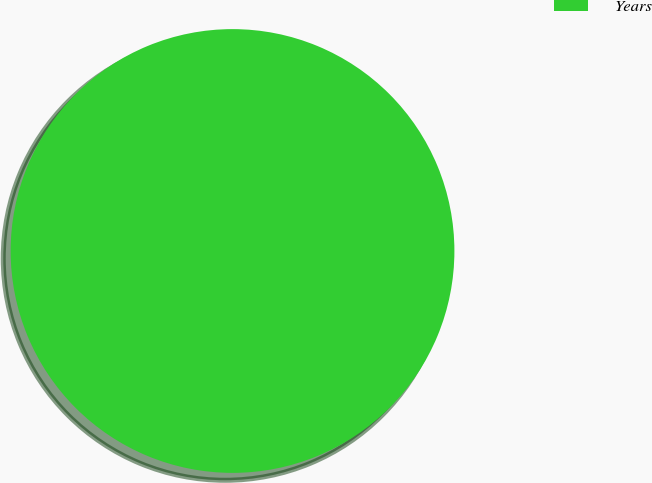Convert chart. <chart><loc_0><loc_0><loc_500><loc_500><pie_chart><fcel>Years<nl><fcel>100.0%<nl></chart> 